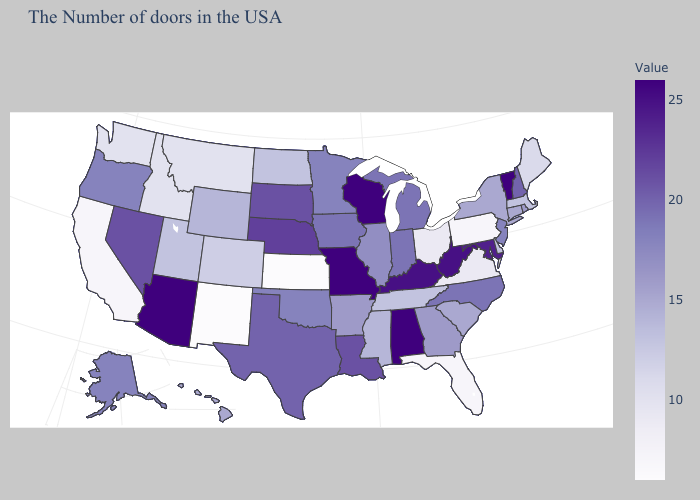Does South Dakota have the highest value in the USA?
Keep it brief. No. Among the states that border Pennsylvania , does Ohio have the lowest value?
Concise answer only. Yes. Which states hav the highest value in the MidWest?
Answer briefly. Wisconsin, Missouri. Does the map have missing data?
Answer briefly. No. 